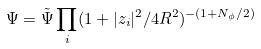Convert formula to latex. <formula><loc_0><loc_0><loc_500><loc_500>\Psi = \tilde { \Psi } \prod _ { i } ( 1 + | z _ { i } | ^ { 2 } / 4 R ^ { 2 } ) ^ { - ( 1 + N _ { \phi } / 2 ) }</formula> 